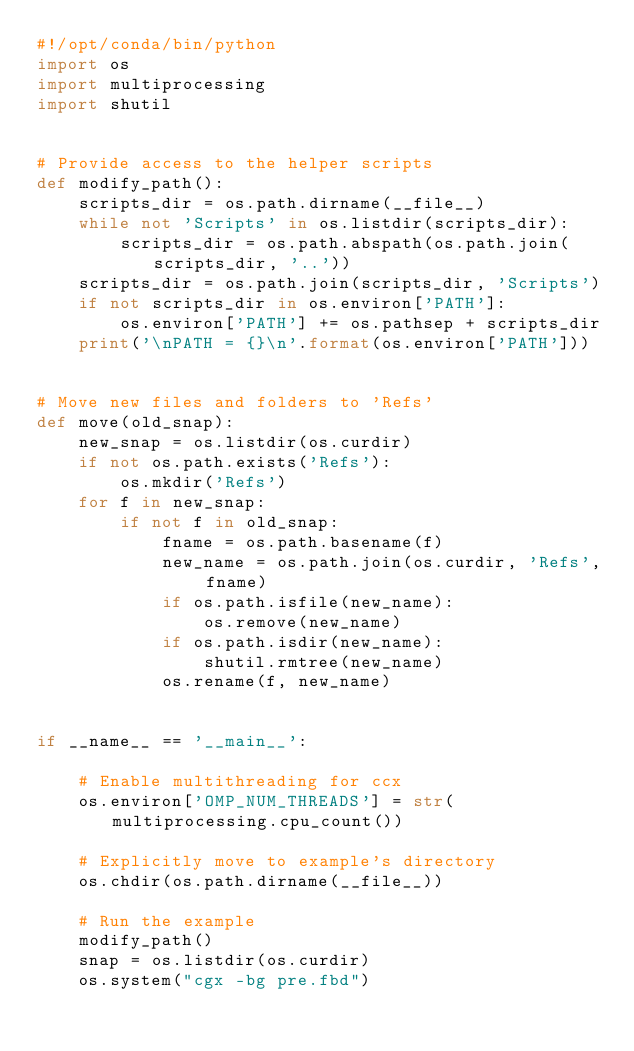<code> <loc_0><loc_0><loc_500><loc_500><_Python_>#!/opt/conda/bin/python
import os
import multiprocessing
import shutil


# Provide access to the helper scripts
def modify_path():
    scripts_dir = os.path.dirname(__file__)
    while not 'Scripts' in os.listdir(scripts_dir):
        scripts_dir = os.path.abspath(os.path.join(scripts_dir, '..'))
    scripts_dir = os.path.join(scripts_dir, 'Scripts')
    if not scripts_dir in os.environ['PATH']:
        os.environ['PATH'] += os.pathsep + scripts_dir
    print('\nPATH = {}\n'.format(os.environ['PATH']))


# Move new files and folders to 'Refs'
def move(old_snap):
    new_snap = os.listdir(os.curdir)
    if not os.path.exists('Refs'):
        os.mkdir('Refs')
    for f in new_snap:
        if not f in old_snap:
            fname = os.path.basename(f)
            new_name = os.path.join(os.curdir, 'Refs', fname)
            if os.path.isfile(new_name):
                os.remove(new_name)
            if os.path.isdir(new_name):
                shutil.rmtree(new_name)
            os.rename(f, new_name)


if __name__ == '__main__':

    # Enable multithreading for ccx
    os.environ['OMP_NUM_THREADS'] = str(multiprocessing.cpu_count())

    # Explicitly move to example's directory
    os.chdir(os.path.dirname(__file__))

    # Run the example
    modify_path()
    snap = os.listdir(os.curdir)
    os.system("cgx -bg pre.fbd")</code> 